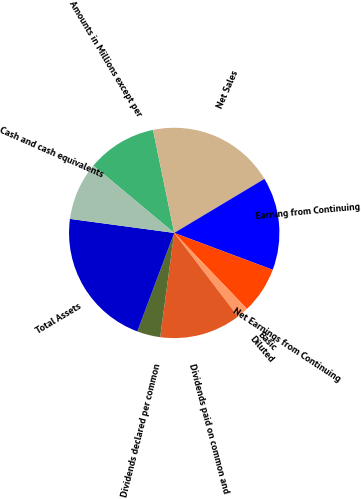Convert chart to OTSL. <chart><loc_0><loc_0><loc_500><loc_500><pie_chart><fcel>Amounts in Millions except per<fcel>Net Sales<fcel>Earning from Continuing<fcel>Net Earnings from Continuing<fcel>Basic<fcel>Diluted<fcel>Dividends paid on common and<fcel>Dividends declared per common<fcel>Total Assets<fcel>Cash and cash equivalents<nl><fcel>10.71%<fcel>19.64%<fcel>14.29%<fcel>7.14%<fcel>0.0%<fcel>1.79%<fcel>12.5%<fcel>3.57%<fcel>21.43%<fcel>8.93%<nl></chart> 